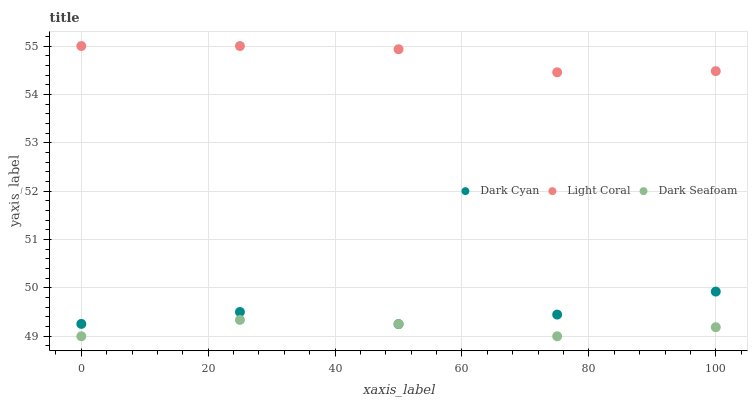Does Dark Seafoam have the minimum area under the curve?
Answer yes or no. Yes. Does Light Coral have the maximum area under the curve?
Answer yes or no. Yes. Does Light Coral have the minimum area under the curve?
Answer yes or no. No. Does Dark Seafoam have the maximum area under the curve?
Answer yes or no. No. Is Light Coral the smoothest?
Answer yes or no. Yes. Is Dark Cyan the roughest?
Answer yes or no. Yes. Is Dark Seafoam the smoothest?
Answer yes or no. No. Is Dark Seafoam the roughest?
Answer yes or no. No. Does Dark Seafoam have the lowest value?
Answer yes or no. Yes. Does Light Coral have the lowest value?
Answer yes or no. No. Does Light Coral have the highest value?
Answer yes or no. Yes. Does Dark Seafoam have the highest value?
Answer yes or no. No. Is Dark Seafoam less than Light Coral?
Answer yes or no. Yes. Is Light Coral greater than Dark Seafoam?
Answer yes or no. Yes. Does Dark Seafoam intersect Dark Cyan?
Answer yes or no. Yes. Is Dark Seafoam less than Dark Cyan?
Answer yes or no. No. Is Dark Seafoam greater than Dark Cyan?
Answer yes or no. No. Does Dark Seafoam intersect Light Coral?
Answer yes or no. No. 